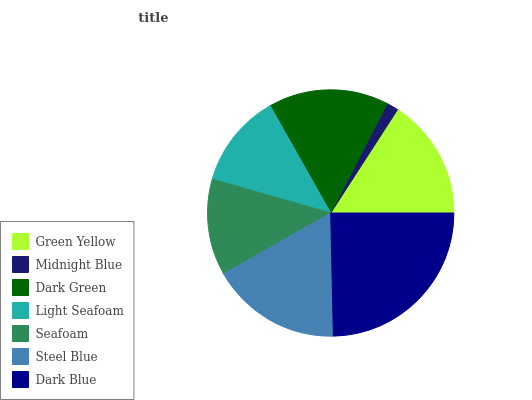Is Midnight Blue the minimum?
Answer yes or no. Yes. Is Dark Blue the maximum?
Answer yes or no. Yes. Is Dark Green the minimum?
Answer yes or no. No. Is Dark Green the maximum?
Answer yes or no. No. Is Dark Green greater than Midnight Blue?
Answer yes or no. Yes. Is Midnight Blue less than Dark Green?
Answer yes or no. Yes. Is Midnight Blue greater than Dark Green?
Answer yes or no. No. Is Dark Green less than Midnight Blue?
Answer yes or no. No. Is Dark Green the high median?
Answer yes or no. Yes. Is Dark Green the low median?
Answer yes or no. Yes. Is Dark Blue the high median?
Answer yes or no. No. Is Steel Blue the low median?
Answer yes or no. No. 